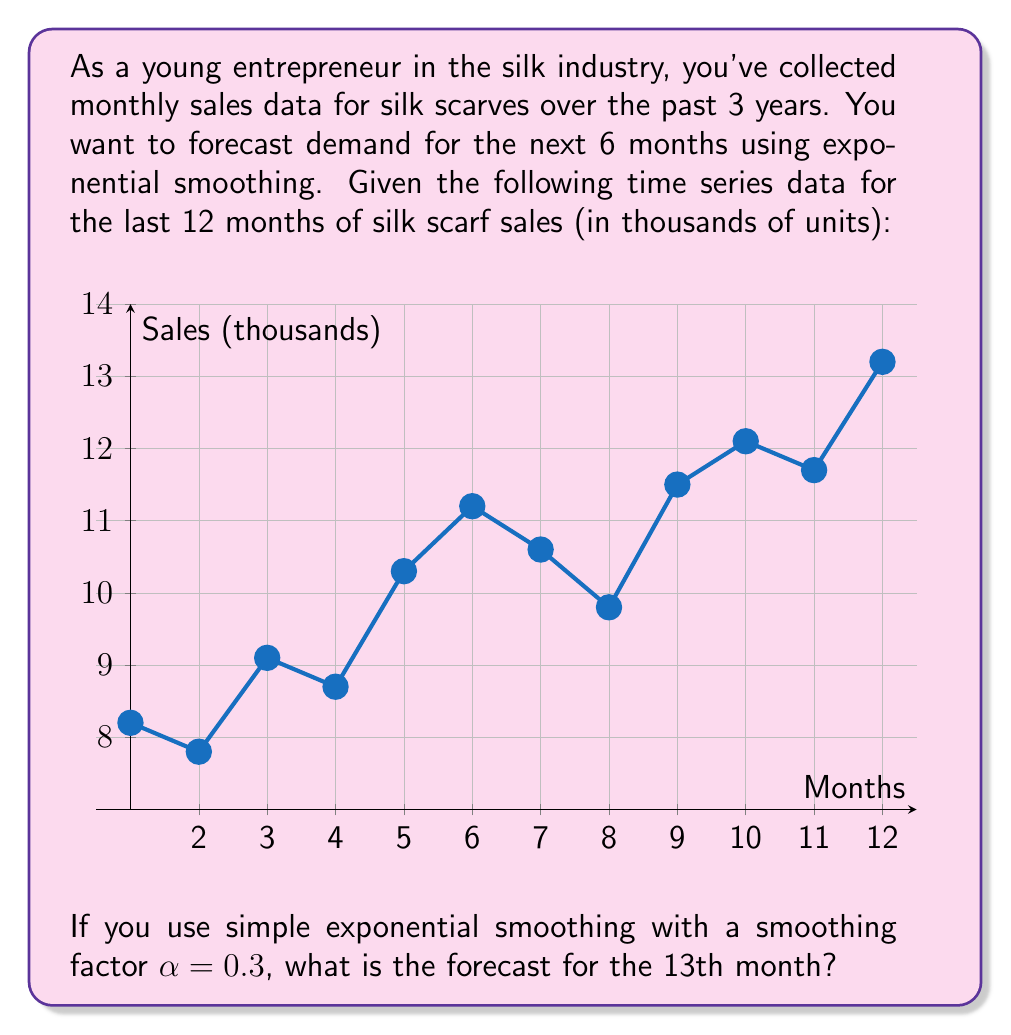Can you answer this question? Let's approach this step-by-step using simple exponential smoothing:

1) The formula for simple exponential smoothing is:
   $$F_{t+1} = \alpha Y_t + (1-\alpha)F_t$$
   where $F_{t+1}$ is the forecast for the next period, $Y_t$ is the actual value at time $t$, and $\alpha$ is the smoothing factor.

2) We're given $\alpha = 0.3$

3) We need to initialize $F_1$. A common method is to use the first observed value. So, $F_1 = 8.2$

4) Now, let's calculate the forecasts for each period:
   $F_2 = 0.3(8.2) + 0.7(8.2) = 8.2$
   $F_3 = 0.3(7.8) + 0.7(8.2) = 8.08$
   $F_4 = 0.3(9.1) + 0.7(8.08) = 8.386$
   ...

5) Continuing this process for all 12 periods, we get:
   $F_{12} = 0.3(11.7) + 0.7(10.79) = 11.093$

6) Finally, for the 13th month:
   $F_{13} = 0.3(13.2) + 0.7(11.093) = 11.7251$

Therefore, the forecast for the 13th month is approximately 11.73 thousand units.
Answer: 11.73 thousand units 